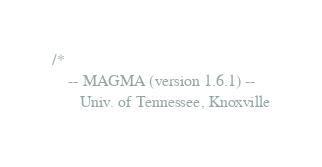<code> <loc_0><loc_0><loc_500><loc_500><_Cuda_>/*
    -- MAGMA (version 1.6.1) --
       Univ. of Tennessee, Knoxville</code> 